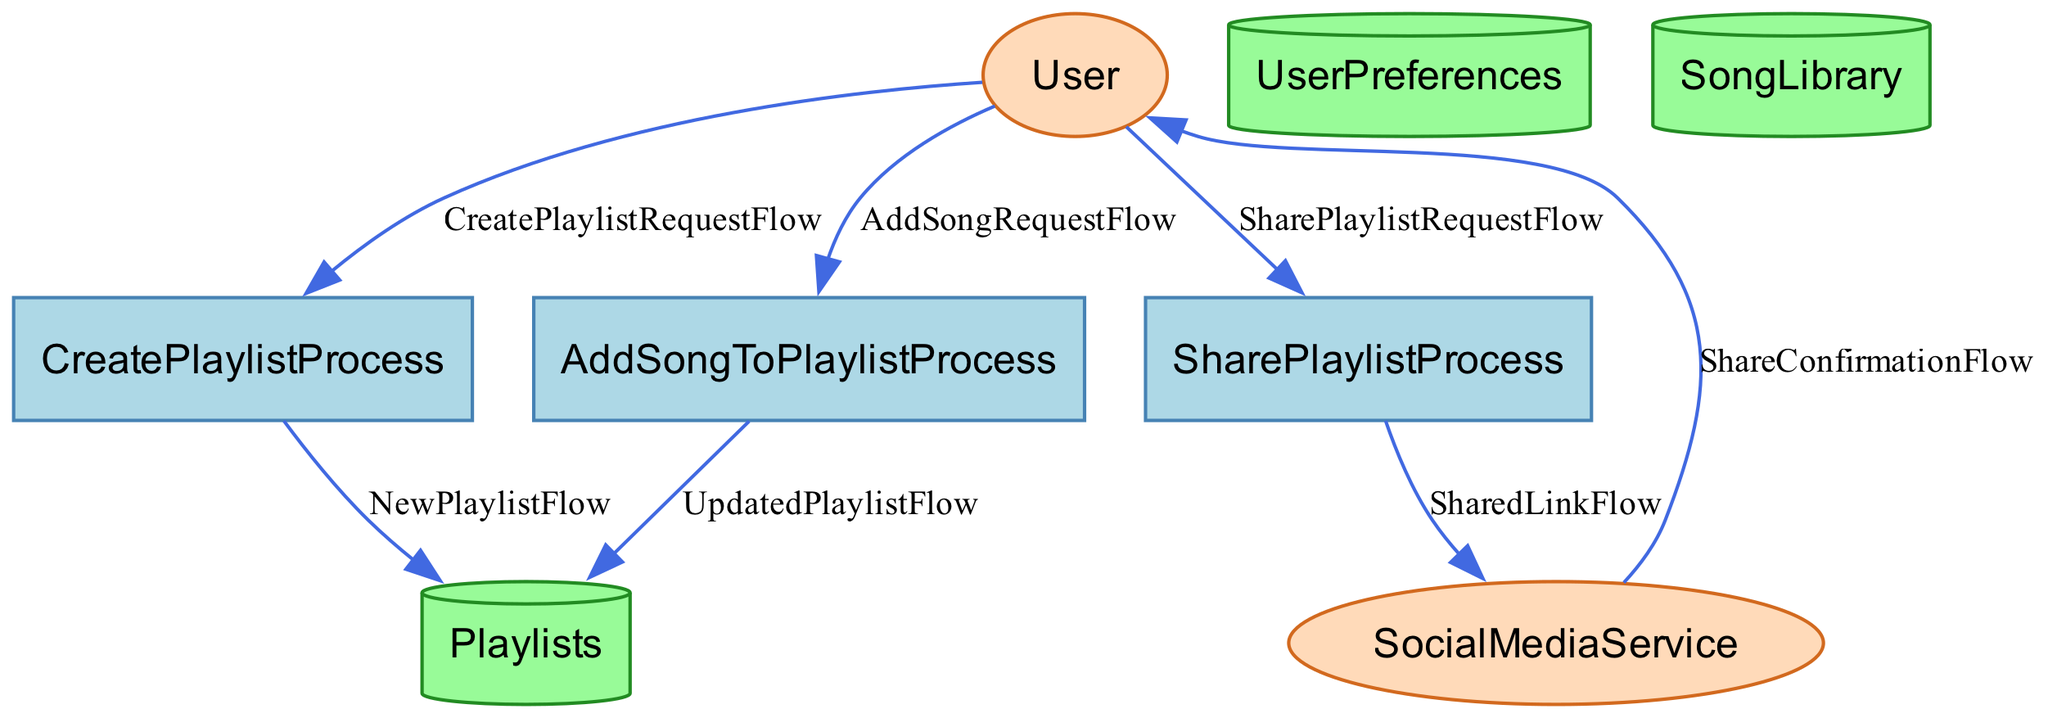What process handles creating a new playlist? The "CreatePlaylistProcess" is responsible for managing the creation of new playlists by the user. It specifically uses input from user preferences and selected songs to produce a new playlist.
Answer: CreatePlaylistProcess How many data stores are present in the diagram? The diagram depicts three data stores, which are "UserPreferences," "Playlists," and "SongLibrary." Each of these stores holds specific types of data relevant to the playlist creation and management process.
Answer: Three What is the output of the "SharePlaylistProcess"? The "SharePlaylistProcess" has two outputs: "SharedLink" and "Confirmation." These outputs represent the link to the shared playlist and a confirmation that the sharing was successful.
Answer: SharedLink, Confirmation What does the "AddSongToPlaylistProcess" use as input? The "AddSongToPlaylistProcess" takes "Playlist" and "SongToAdd" as inputs. This means the process relies on the existing playlist and the specific song that the user wants to add.
Answer: Playlist and SongToAdd What entity interacts with the "SocialMediaService"? The "SharePlaylistProcess" sends the "SharedLink" to the "SocialMediaService." This interaction is for sharing the playlist link on social media platforms.
Answer: SocialMediaService What is the flow that confirms a successful playlist share? The "ShareConfirmationFlow" depicts the flow of confirmation that is sent from the "SocialMediaService" to the "User," indicating that the playlist has been successfully shared.
Answer: ShareConfirmationFlow 